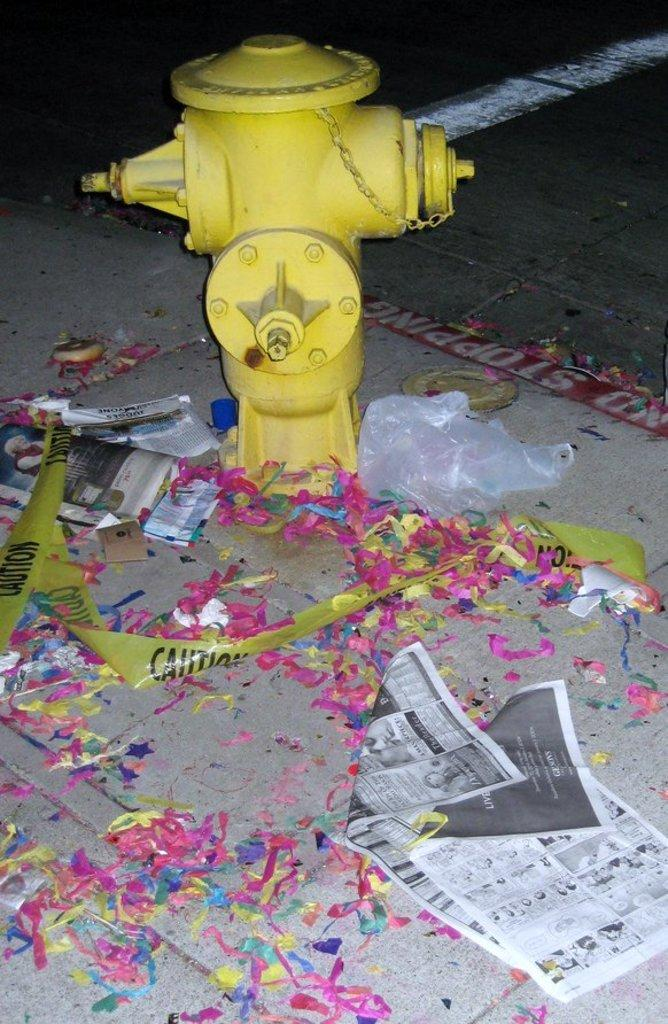What object can be seen in the image that is used for firefighting? There is a fire hydrant in the image. What color is the fire hydrant? The fire hydrant is yellow. What else can be seen on the land in the image? There are papers on the land in the image. How many mice can be seen hiding behind the fire hydrant in the image? There are no mice present in the image. What type of teeth can be seen on the fire hydrant in the image? Fire hydrants do not have teeth, so there are no teeth visible on the fire hydrant in the image. 